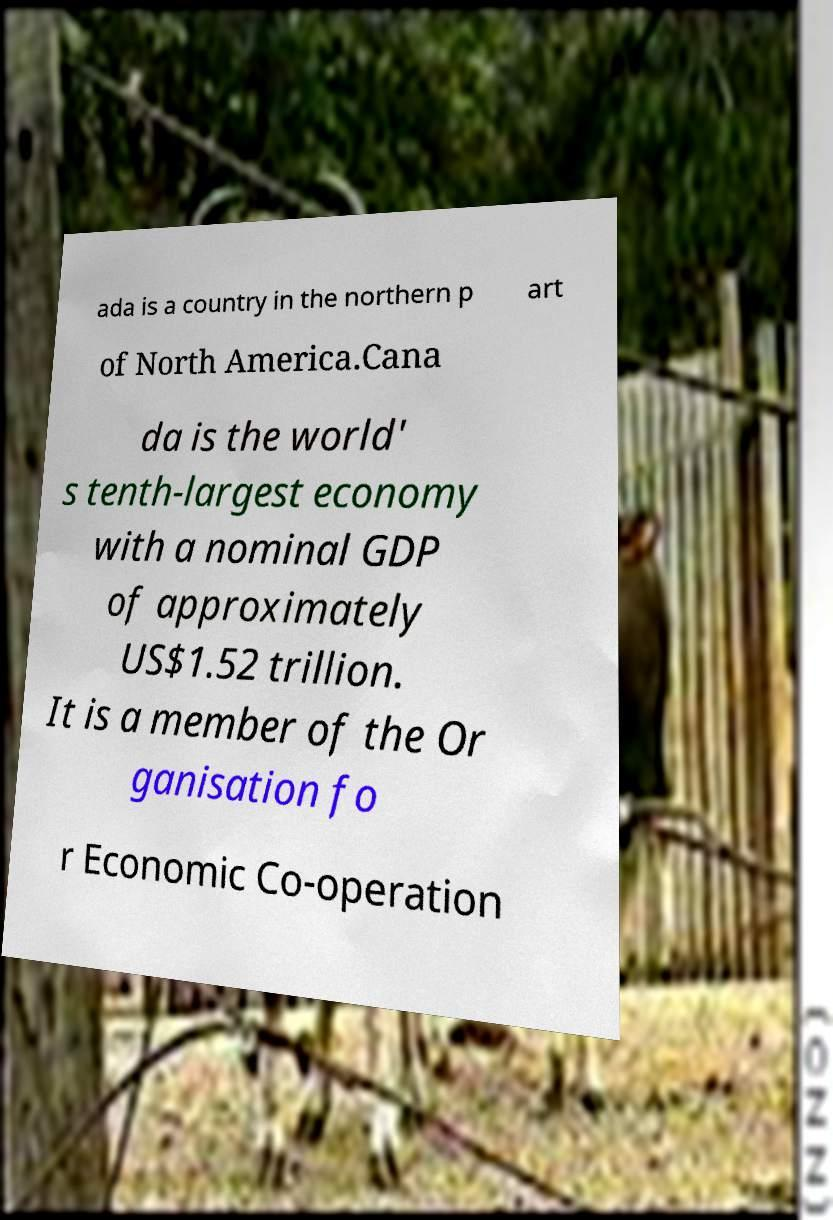Can you read and provide the text displayed in the image?This photo seems to have some interesting text. Can you extract and type it out for me? ada is a country in the northern p art of North America.Cana da is the world' s tenth-largest economy with a nominal GDP of approximately US$1.52 trillion. It is a member of the Or ganisation fo r Economic Co-operation 